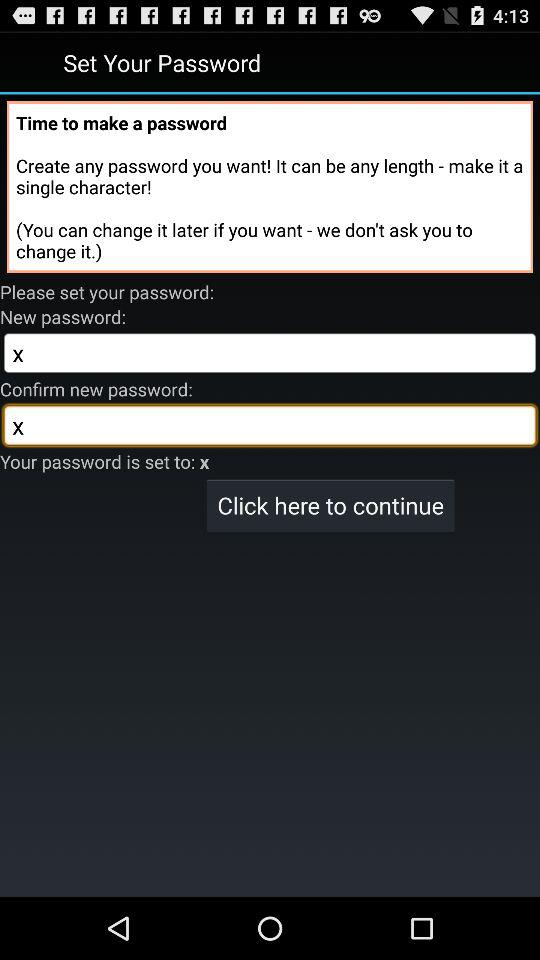What is the new password? The new password is "x". 